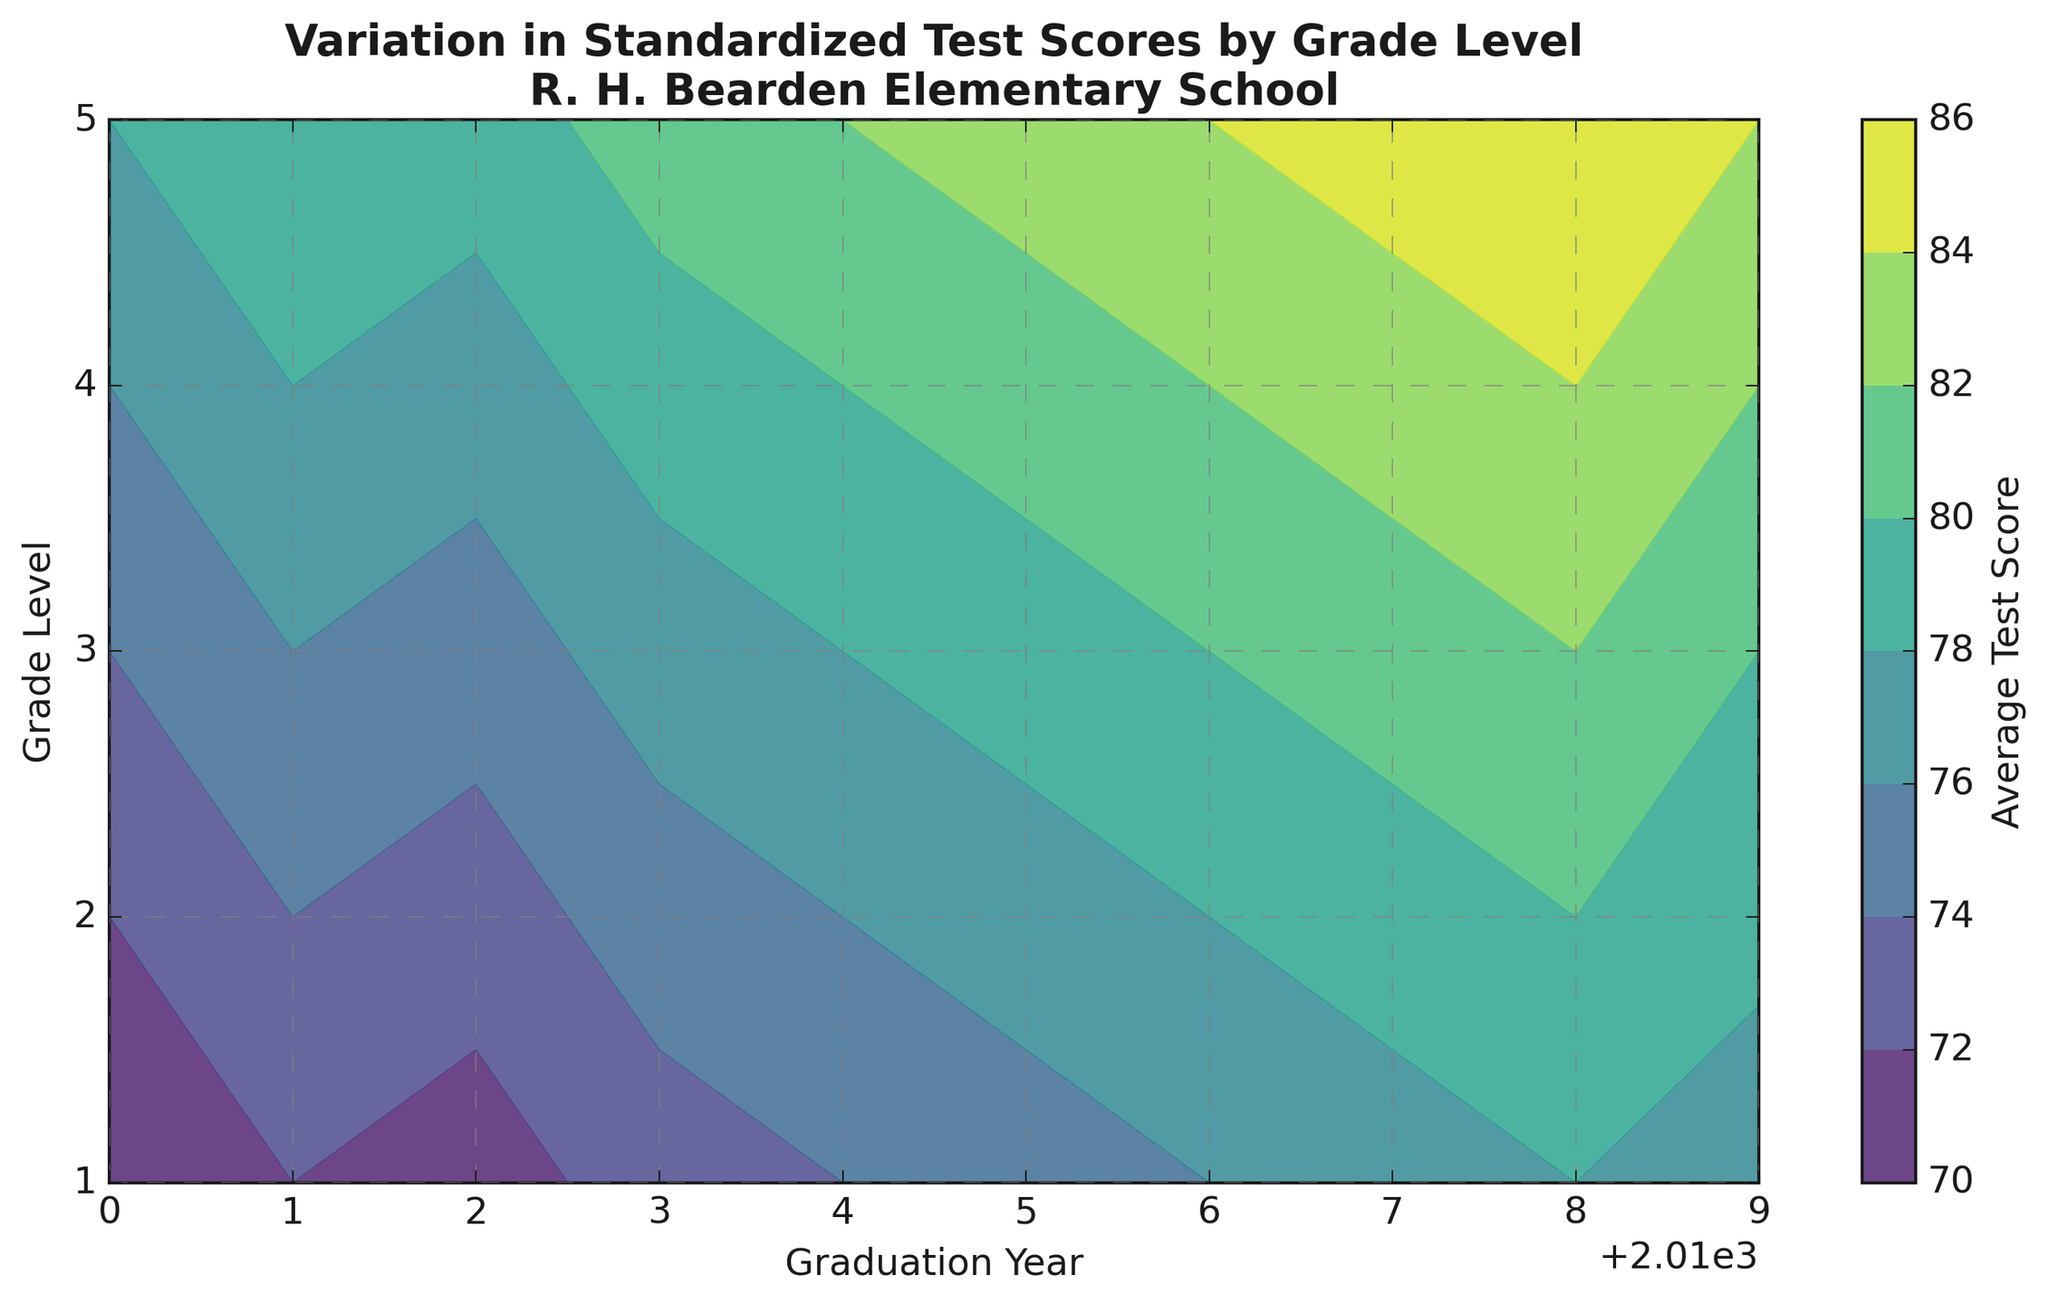What is the average test score for 1st graders in 2015? Find the test score for 1st grade in 2015 on the contour plot.
Answer: 75 Which grade level had the highest average test score in 2019? Locate the highest contour value for 2019 on the figure and see which grade level it aligns with.
Answer: 5 What is the difference in average test scores between 2nd grade in 2018 and 2nd grade in 2010? Look at the contour plot to find the test scores for 2nd grade in 2018 and 2010, then compute the difference (80 - 72).
Answer: 8 How does the average test score of 4th grade in 2014 compare to 3rd grade in 2013? Find the test score for 4th grade in 2014 and 3rd grade in 2013 on the contour plot, then compare the two values (80 vs 77).
Answer: Higher What is the median test score for 3rd graders from 2010 to 2019? List all the test scores for 3rd grade from 2010-2019: 74, 76, 75, 77, 78, 79, 80, 81, 82, 80 and arrange them in ascending order. Then find the median value.
Answer: 78 What is the total sum of all average test scores for 5th grade from 2010 to 2019? Add all the average test scores for 5th grade over the years 2010-2019: 78, 80, 79, 81, 82, 83, 84, 85, 86, 84.
Answer: 832 In which year did the 1st graders have the lowest average test score? Look at the contour plot for 1st grade and identify the lowest value and its corresponding year.
Answer: 2010 How has the average test score of 2nd grade changed from 2010 to 2019? Compare the test score for 2nd grade in 2010 and 2019 (72 vs 79), and describe whether it increased or decreased.
Answer: Increased What is the range of test scores for 4th grade from 2010 to 2019? Identify the highest and lowest test scores for 4th grade (84 in 2018 and 76 in 2010) and compute the range (84 - 76).
Answer: 8 How do the test scores for 1st and 3rd grades in 2016 compare? Check the average test scores for 1st and 3rd grades in 2016 on the contour plot and compare them (76 vs 80).
Answer: 3rd grade higher 